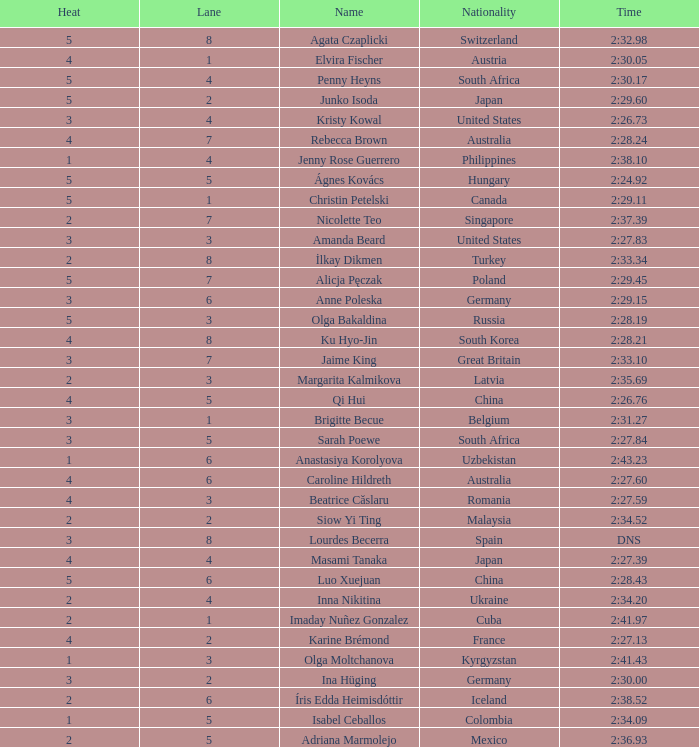What is the name that saw 4 heats and a lane higher than 7? Ku Hyo-Jin. 